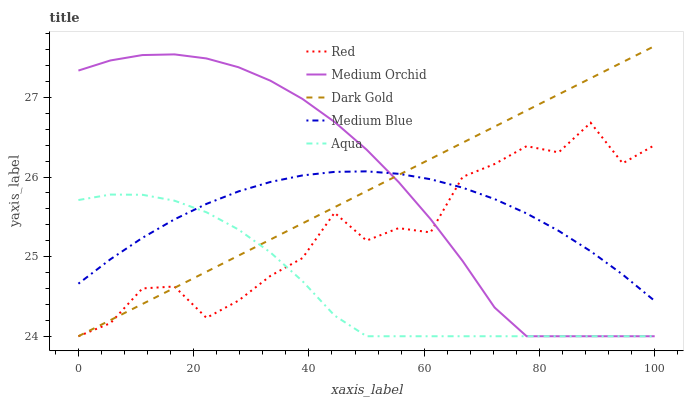Does Aqua have the minimum area under the curve?
Answer yes or no. Yes. Does Medium Orchid have the maximum area under the curve?
Answer yes or no. Yes. Does Medium Blue have the minimum area under the curve?
Answer yes or no. No. Does Medium Blue have the maximum area under the curve?
Answer yes or no. No. Is Dark Gold the smoothest?
Answer yes or no. Yes. Is Red the roughest?
Answer yes or no. Yes. Is Medium Orchid the smoothest?
Answer yes or no. No. Is Medium Orchid the roughest?
Answer yes or no. No. Does Medium Blue have the lowest value?
Answer yes or no. No. Does Dark Gold have the highest value?
Answer yes or no. Yes. Does Medium Orchid have the highest value?
Answer yes or no. No. Does Medium Blue intersect Red?
Answer yes or no. Yes. Is Medium Blue less than Red?
Answer yes or no. No. Is Medium Blue greater than Red?
Answer yes or no. No. 